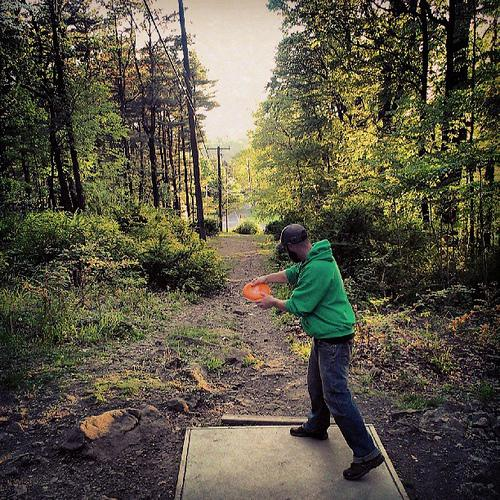Question: who is standing in this picture?
Choices:
A. A woman.
B. A boy.
C. A teenager.
D. A man.
Answer with the letter. Answer: D Question: why is the man holding a frisbee?
Choices:
A. To carry it to the car.
B. He is preparing to throw a frisbee.
C. Taking it to the park.
D. Getting it for a child.
Answer with the letter. Answer: B Question: what time of day is it?
Choices:
A. Daytime.
B. Afternoon.
C. Evening.
D. Morning.
Answer with the letter. Answer: A Question: what kind of pants is the man wearing?
Choices:
A. Cotton.
B. Courderoy.
C. Jeans.
D. Polyester.
Answer with the letter. Answer: C Question: what color is the frisbee?
Choices:
A. Red.
B. White.
C. Blue.
D. Orange.
Answer with the letter. Answer: D Question: where is this picture taken?
Choices:
A. On a street.
B. In the house.
C. In the yard.
D. In the woods.
Answer with the letter. Answer: D 